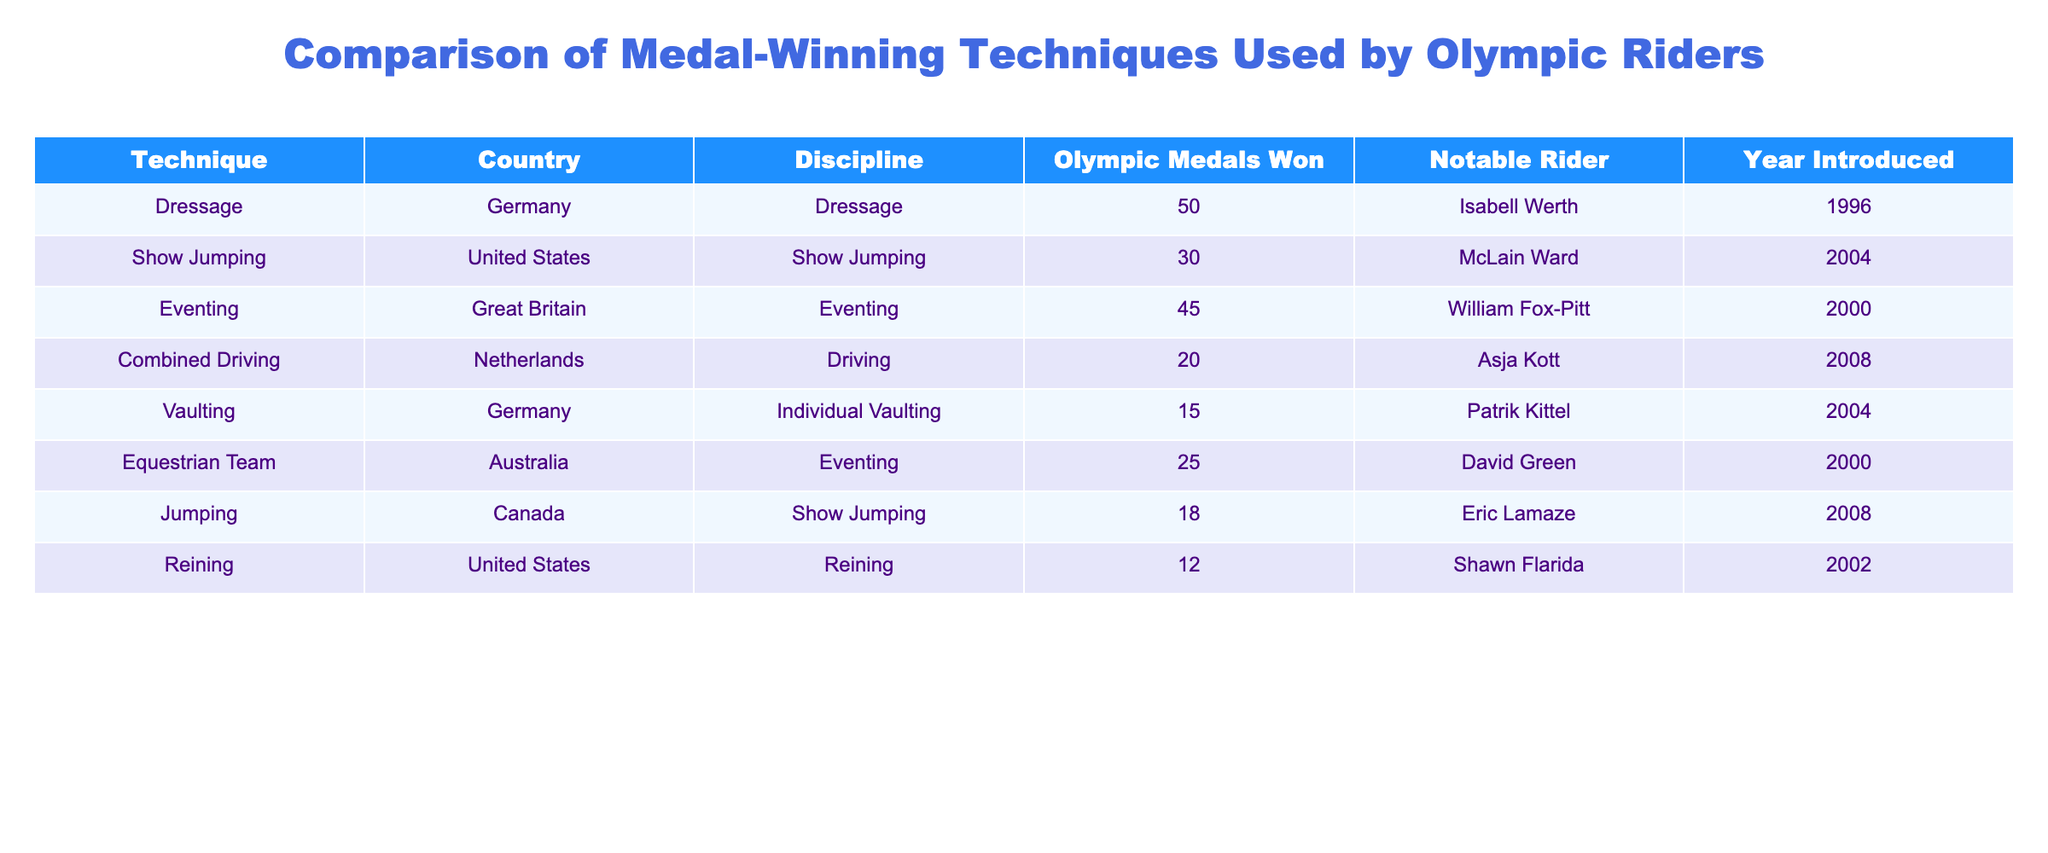What technique has won the most Olympic medals? By scanning the "Olympic Medals Won" column, it is clear that the technique "Dressage" from Germany has won the highest number of Olympic medals, totaling 50.
Answer: 50 Which country is associated with the discipline of Show Jumping? The "Country" column shows that both the United States and Canada are associated with Show Jumping, with the United States having won 30 medals and Canada 18 medals for this discipline.
Answer: United States and Canada What is the total number of Olympic medals won by Eventing techniques from both Great Britain and Australia? To find the total, we add the Olympic medals won by Great Britain (45) and Australia (25). Therefore, 45 + 25 = 70.
Answer: 70 Is it true that the United States has the highest number of medals in both Reining and Show Jumping? In Reining, the United States has won 12 medals, while in Show Jumping, they have won 30 medals compared to Canada’s 18 medals. Since the U.S. has the higher winning count in Show Jumping but is not represented in other disciplines listed, it could be true. Therefore, the assertion pertains only to one discipline.
Answer: No How many techniques were introduced in 2004, and which countries are they from? By reviewing the "Year Introduced" column, we identify that two techniques were introduced in 2004: Dressage from Germany and Show Jumping from the United States. Thus, the technique count is two.
Answer: 2 (Germany, United States) What is the median number of Olympic medals won across all disciplines listed in the table? First, we arrange the medal counts in ascending order: 12, 15, 18, 20, 25, 30, 45, 50 (with notable riders accounted). There are 8 values (even number), so the median will be the average of the two middle values (20 and 25). Thus, (20 + 25) / 2 = 22.5.
Answer: 22.5 Which discipline has the least number of Olympic medals won and who is the notable rider? Reviewing the "Olympic Medals Won" column, "Reining" has the least medals with a total of 12, whose notable rider is Shawn Flarida.
Answer: Reining, Shawn Flarida Has the technique of Vaulting produced a notable rider who has won an Olympic medal? Vaulting is noted in the table with 15 medals won, and the notable rider named is Patrik Kittel, hence confirming that it does link to medal-winning.
Answer: Yes What is the total number of Olympic medals won by all techniques from Germany? The table shows Dressage with 50 medals and Vaulting with 15 medals, summing them gives 50 + 15 = 65 medals for Germany.
Answer: 65 